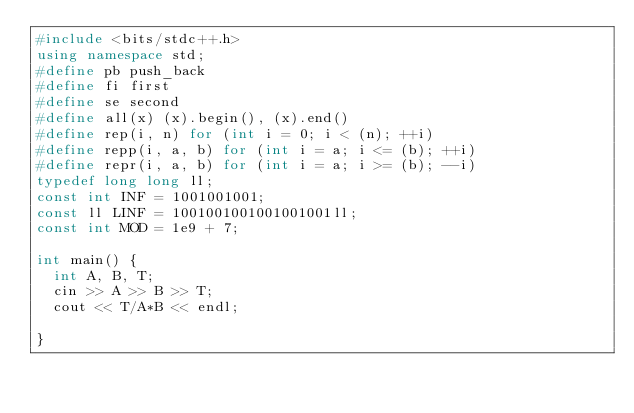Convert code to text. <code><loc_0><loc_0><loc_500><loc_500><_C++_>#include <bits/stdc++.h>
using namespace std;
#define pb push_back
#define fi first
#define se second
#define all(x) (x).begin(), (x).end()
#define rep(i, n) for (int i = 0; i < (n); ++i)
#define repp(i, a, b) for (int i = a; i <= (b); ++i)
#define repr(i, a, b) for (int i = a; i >= (b); --i)
typedef long long ll;
const int INF = 1001001001;
const ll LINF = 1001001001001001001ll;
const int MOD = 1e9 + 7;

int main() {
  int A, B, T;
  cin >> A >> B >> T;
  cout << T/A*B << endl;
  
}</code> 